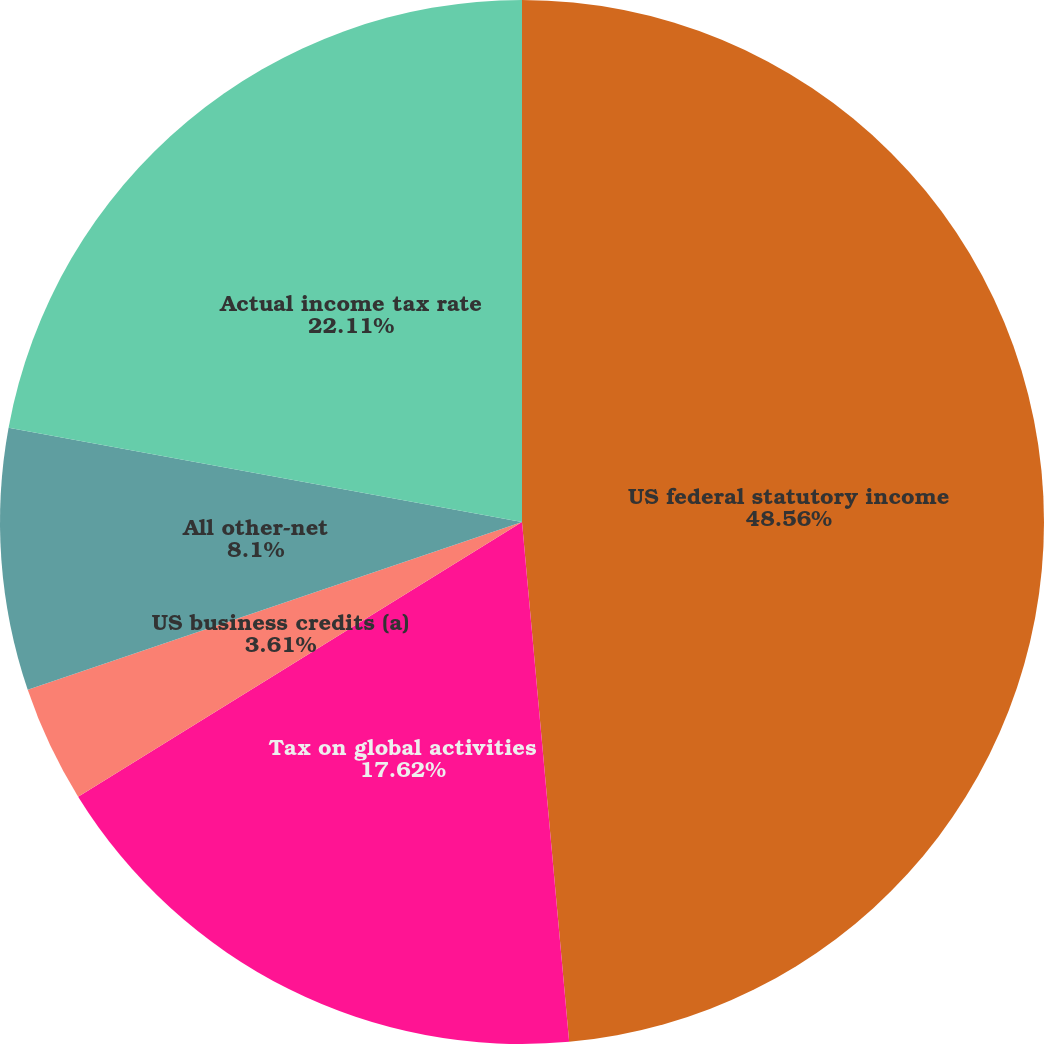<chart> <loc_0><loc_0><loc_500><loc_500><pie_chart><fcel>US federal statutory income<fcel>Tax on global activities<fcel>US business credits (a)<fcel>All other-net<fcel>Actual income tax rate<nl><fcel>48.56%<fcel>17.62%<fcel>3.61%<fcel>8.1%<fcel>22.11%<nl></chart> 